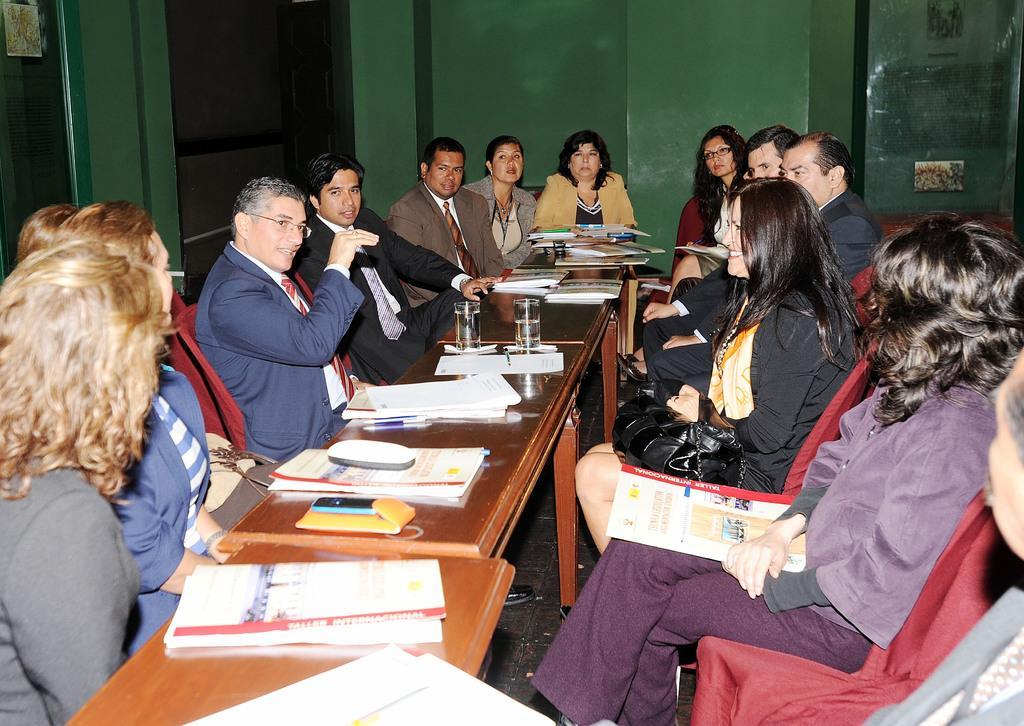Please provide a concise description of this image. In this image I can see few people are sitting on the chairs around the table. Some papers, mobile phones, glasses, books are placed on this tablet. Everyone are in formal dress and discussing something. It seems like a meeting hall. In the background I can see a wall and a door. 